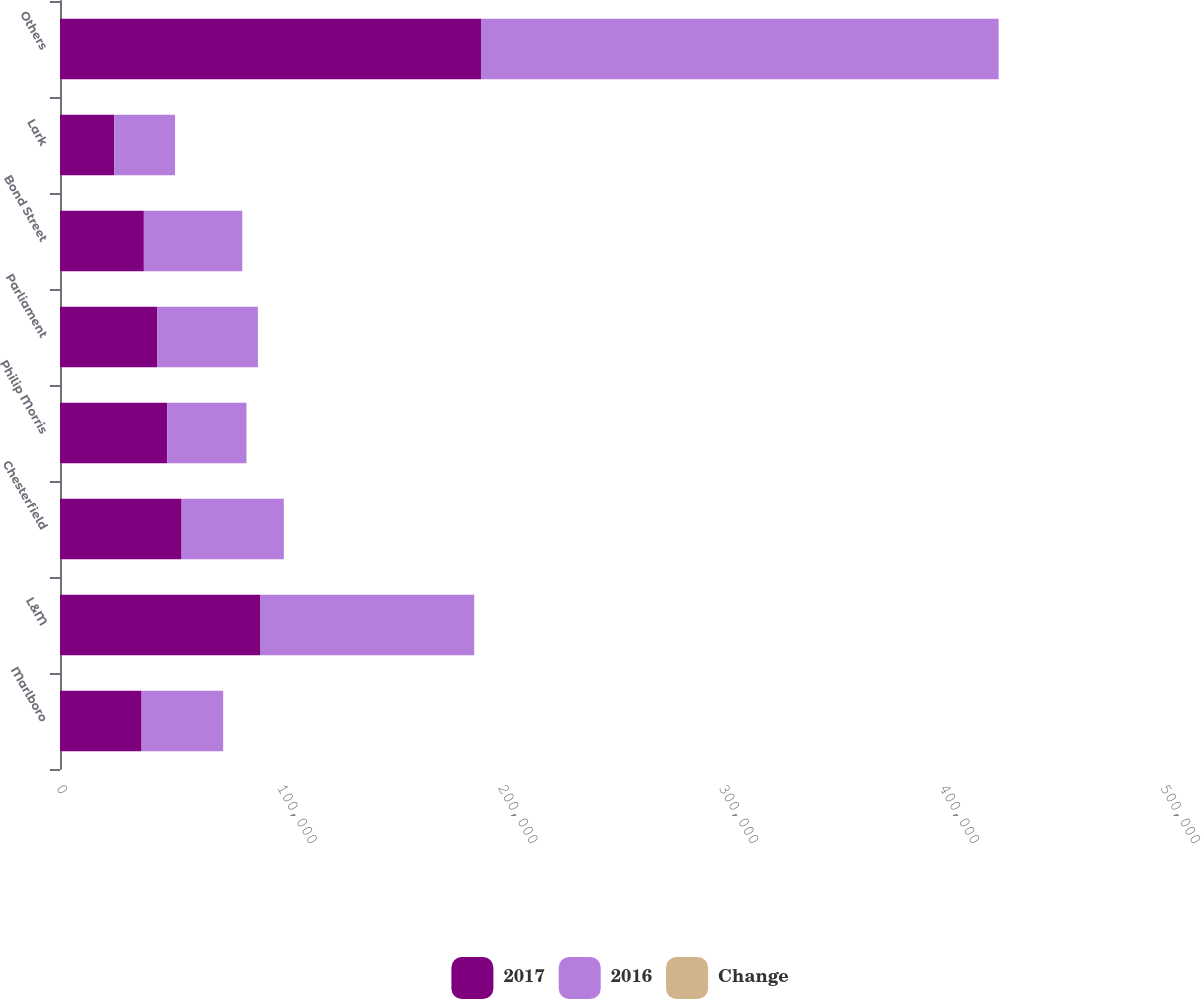Convert chart. <chart><loc_0><loc_0><loc_500><loc_500><stacked_bar_chart><ecel><fcel>Marlboro<fcel>L&M<fcel>Chesterfield<fcel>Philip Morris<fcel>Parliament<fcel>Bond Street<fcel>Lark<fcel>Others<nl><fcel>2017<fcel>36950.5<fcel>90817<fcel>55075<fcel>48522<fcel>43965<fcel>37987<fcel>24530<fcel>190664<nl><fcel>2016<fcel>36950.5<fcel>96770<fcel>46291<fcel>35914<fcel>45671<fcel>44567<fcel>27571<fcel>234442<nl><fcel>Change<fcel>4<fcel>6.2<fcel>19<fcel>35.1<fcel>3.7<fcel>14.8<fcel>11<fcel>18.7<nl></chart> 